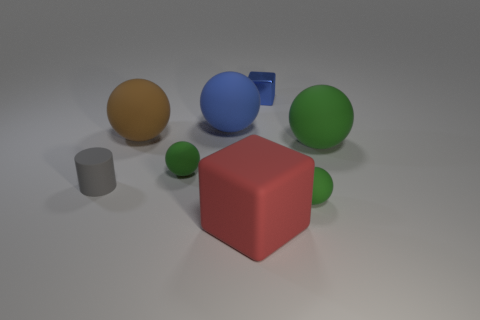Subtract 3 spheres. How many spheres are left? 2 Subtract all blue cubes. How many cubes are left? 1 Subtract all brown matte spheres. How many spheres are left? 4 Subtract all cubes. How many objects are left? 6 Subtract all green blocks. Subtract all red spheres. How many blocks are left? 2 Subtract all blue blocks. How many brown cylinders are left? 0 Subtract all tiny green objects. Subtract all big blue spheres. How many objects are left? 5 Add 6 small metallic blocks. How many small metallic blocks are left? 7 Add 2 shiny cubes. How many shiny cubes exist? 3 Add 2 cyan metallic objects. How many objects exist? 10 